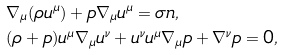Convert formula to latex. <formula><loc_0><loc_0><loc_500><loc_500>& \nabla _ { \mu } ( \rho u ^ { \mu } ) + p \nabla _ { \mu } u ^ { \mu } = \sigma n , \\ & ( \rho + p ) u ^ { \mu } \nabla _ { \mu } u ^ { \nu } + u ^ { \nu } u ^ { \mu } \nabla _ { \mu } p + \nabla ^ { \nu } p = 0 ,</formula> 